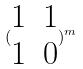<formula> <loc_0><loc_0><loc_500><loc_500>( \begin{matrix} 1 & 1 \\ 1 & 0 \end{matrix} ) ^ { m }</formula> 